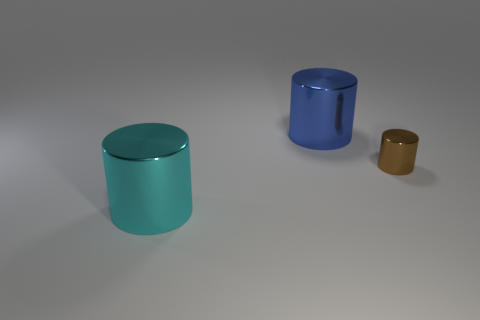Are there any tiny things of the same color as the small shiny cylinder?
Provide a succinct answer. No. Do the big cyan thing and the cylinder that is to the right of the blue metallic object have the same material?
Provide a succinct answer. Yes. Are there any large metal objects that are in front of the large object on the left side of the blue cylinder?
Ensure brevity in your answer.  No. What is the color of the shiny cylinder that is on the left side of the tiny brown cylinder and in front of the blue cylinder?
Offer a very short reply. Cyan. How big is the blue metallic cylinder?
Your answer should be very brief. Large. How many things are the same size as the cyan cylinder?
Offer a very short reply. 1. Are the cylinder that is in front of the small brown thing and the large cylinder behind the small object made of the same material?
Ensure brevity in your answer.  Yes. What is the big cylinder in front of the large object that is right of the big cyan metallic cylinder made of?
Your response must be concise. Metal. What is the big cylinder behind the large cyan cylinder made of?
Make the answer very short. Metal. What number of other things have the same shape as the brown thing?
Your response must be concise. 2. 